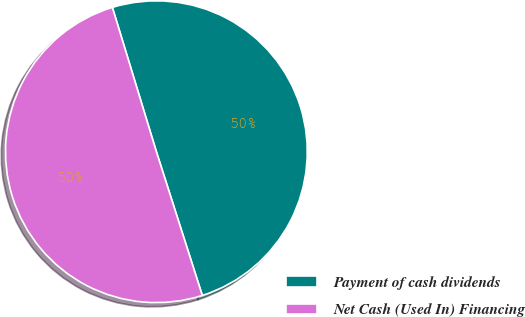Convert chart to OTSL. <chart><loc_0><loc_0><loc_500><loc_500><pie_chart><fcel>Payment of cash dividends<fcel>Net Cash (Used In) Financing<nl><fcel>49.79%<fcel>50.21%<nl></chart> 